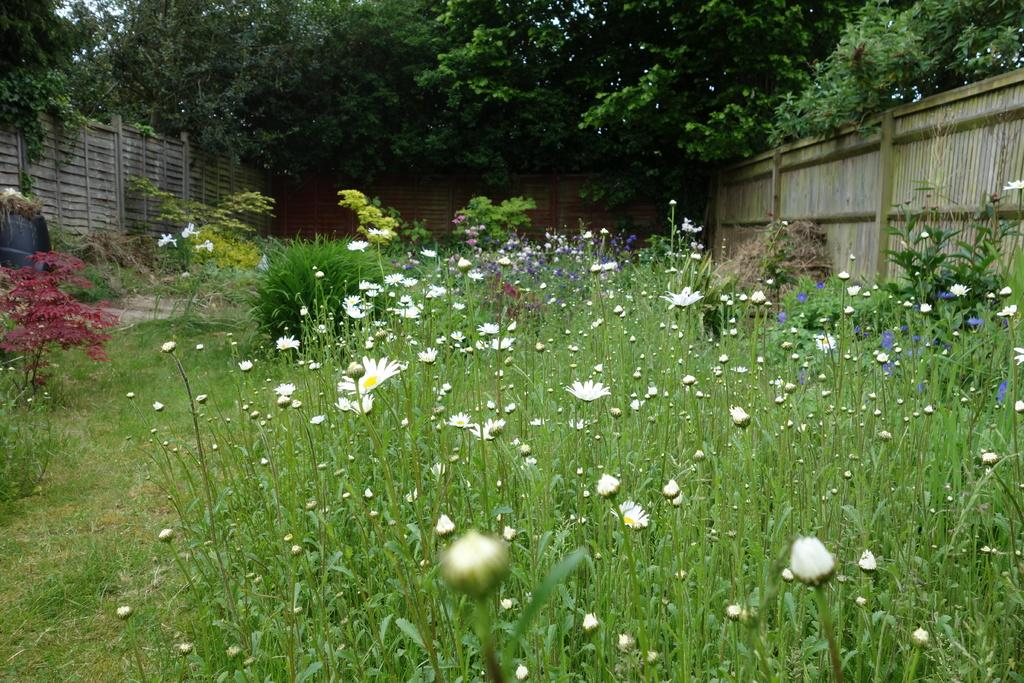What type of plants can be seen in the image? There are plants with different color flowers in the image. What is located on either side of the plants? There is fencing on either side of the plants. What can be seen in the background of the image? There are trees visible at the top of the image. How many units of underwear are hanging on the trees in the image? There are no units of underwear present in the image; it features plants with different color flowers, fencing, and trees. 